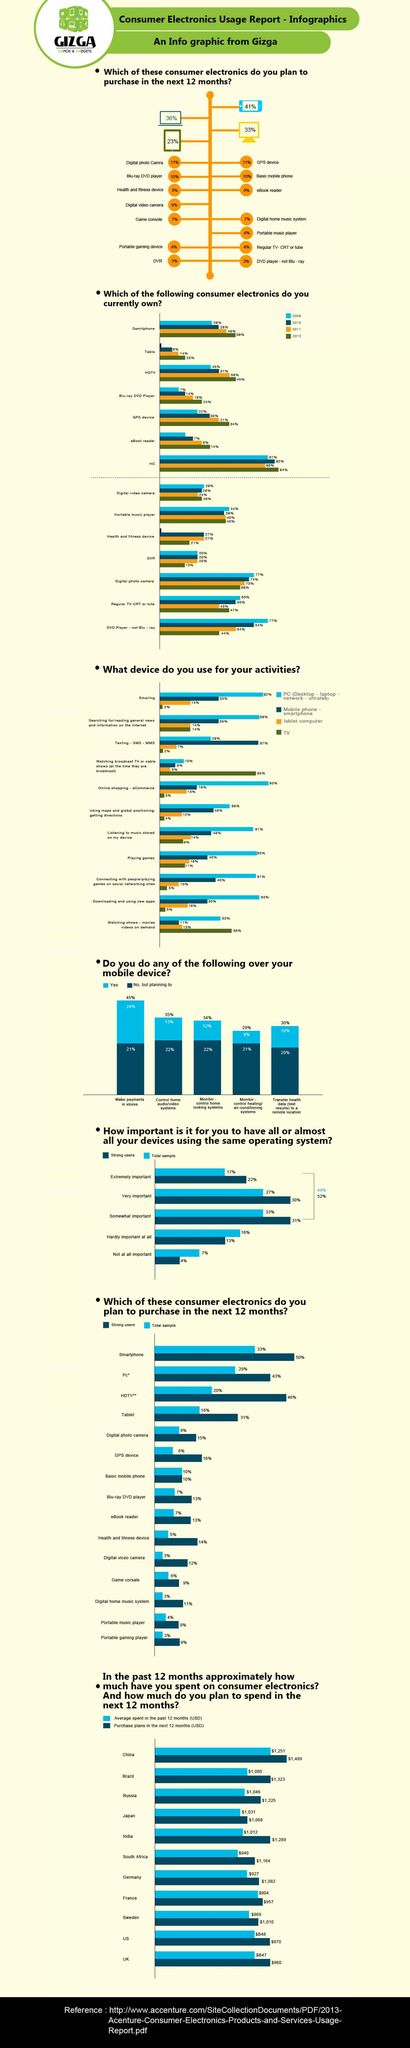What percentage of people own a smartphone in 2011 according to the consumer electronics usage report of Gizga?
Answer the question with a short phrase. 48% How much money is planned to spent (in USD) on consumer electronics in the next 12 months in Russia according to the consumer electronics usage report of Gizga? $1,225 What is the average spent (in USD) on consumer electronics in the past 12 months in India as per the report? $1,012 What percentage of people own a eBoot reader in 2012 according to the consumer electronics usage report of Gizga? 14% Which country has showed the highest average spent (in USD) on consumer electronics in the past 12 months among the given countries as per the report? China What percentage of people make payments in stores through their mobile device as per the consumer electronics usage report from Gizga? 24% What percentage of people own a digital photo camera in 2009 according to the consumer electronics usage report of Gizga? 77% What percentage of  people use monitor-control home locking system through their mobile device as per the report? 12% 